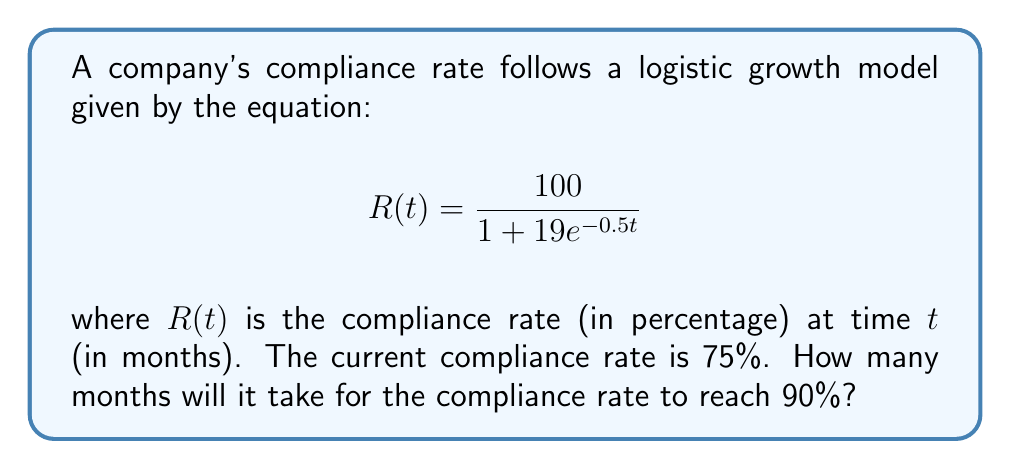Give your solution to this math problem. To solve this problem, we'll follow these steps:

1) We know that we want to find $t$ when $R(t) = 90$. So, we set up the equation:

   $$90 = \frac{100}{1 + 19e^{-0.5t}}$$

2) Multiply both sides by the denominator:

   $$90(1 + 19e^{-0.5t}) = 100$$

3) Distribute on the left side:

   $$90 + 1710e^{-0.5t} = 100$$

4) Subtract 90 from both sides:

   $$1710e^{-0.5t} = 10$$

5) Divide both sides by 1710:

   $$e^{-0.5t} = \frac{10}{1710} \approx 0.005848$$

6) Take the natural log of both sides:

   $$-0.5t = \ln(0.005848)$$

7) Divide both sides by -0.5:

   $$t = \frac{\ln(0.005848)}{-0.5} \approx 10.46$$

8) Since we're dealing with months, we round up to the nearest whole number.

Therefore, it will take 11 months for the compliance rate to reach 90%.
Answer: 11 months 